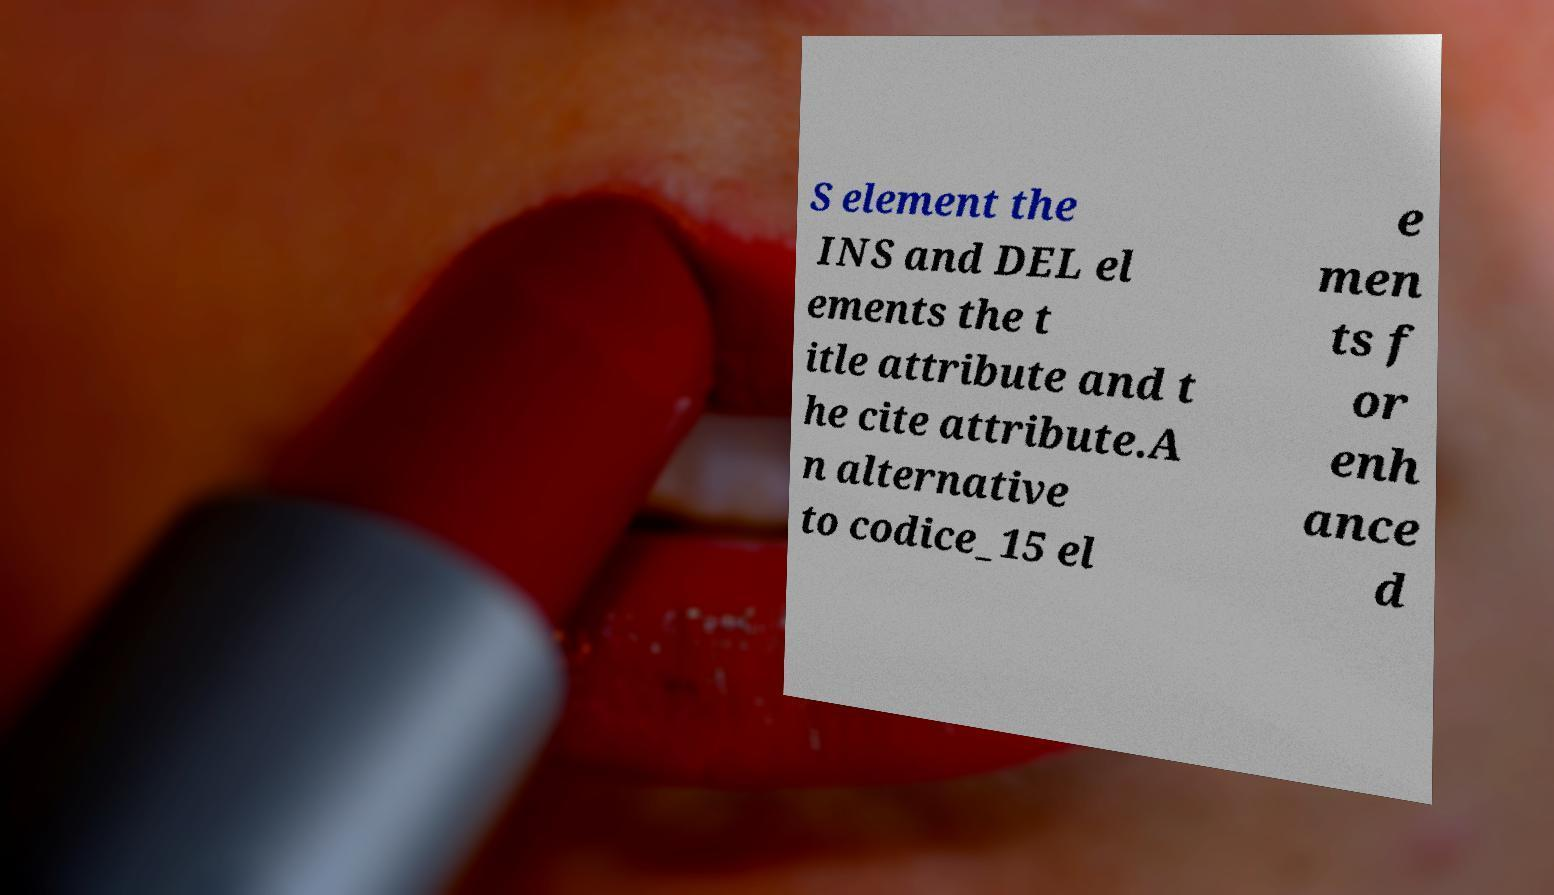I need the written content from this picture converted into text. Can you do that? S element the INS and DEL el ements the t itle attribute and t he cite attribute.A n alternative to codice_15 el e men ts f or enh ance d 